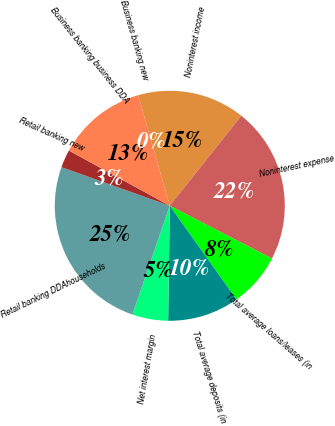Convert chart. <chart><loc_0><loc_0><loc_500><loc_500><pie_chart><fcel>Noninterest income<fcel>Noninterest expense<fcel>Total average loans/leases (in<fcel>Total average deposits (in<fcel>Net interest margin<fcel>Retail banking DDAhouseholds<fcel>Retail banking new<fcel>Business banking business DDA<fcel>Business banking new<nl><fcel>15.12%<fcel>21.9%<fcel>7.56%<fcel>10.08%<fcel>5.04%<fcel>25.19%<fcel>2.52%<fcel>12.6%<fcel>0.0%<nl></chart> 